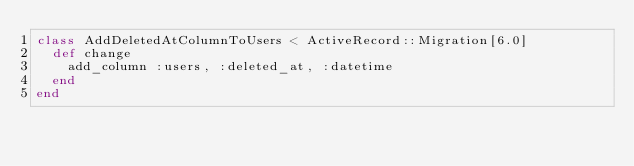Convert code to text. <code><loc_0><loc_0><loc_500><loc_500><_Ruby_>class AddDeletedAtColumnToUsers < ActiveRecord::Migration[6.0]
  def change
    add_column :users, :deleted_at, :datetime
  end
end
</code> 